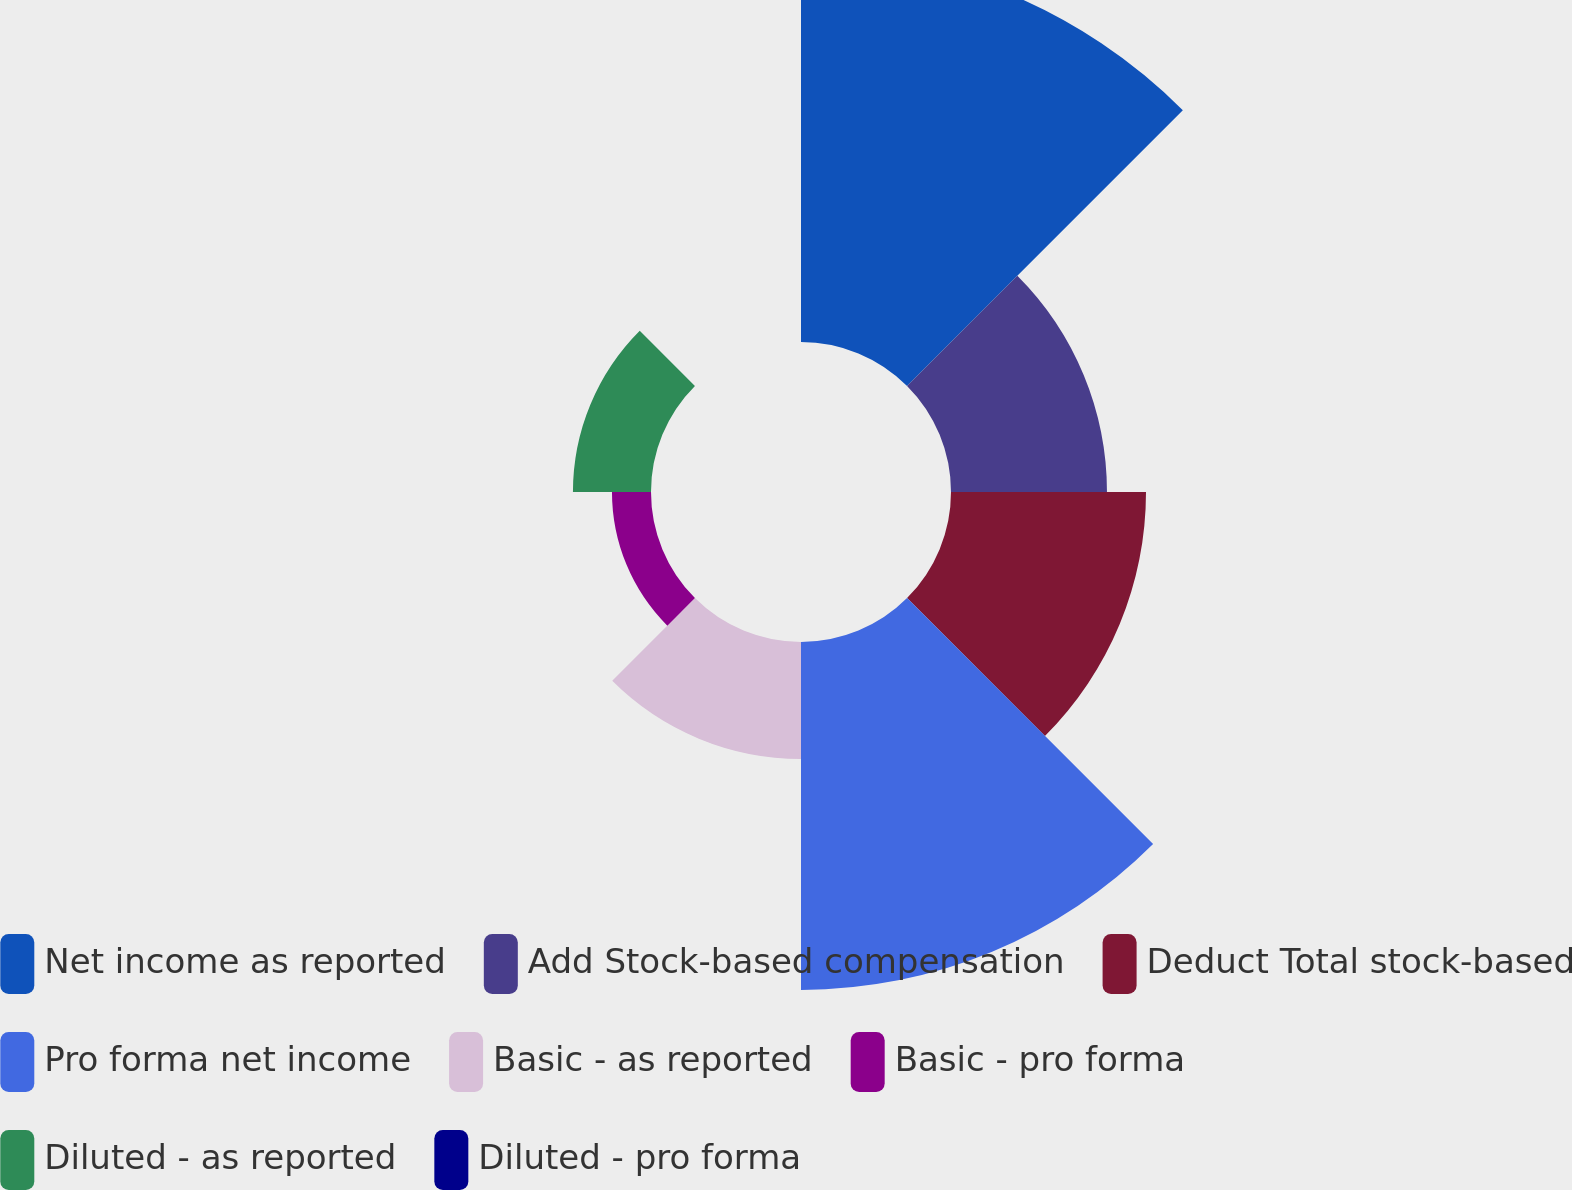<chart> <loc_0><loc_0><loc_500><loc_500><pie_chart><fcel>Net income as reported<fcel>Add Stock-based compensation<fcel>Deduct Total stock-based<fcel>Pro forma net income<fcel>Basic - as reported<fcel>Basic - pro forma<fcel>Diluted - as reported<fcel>Diluted - pro forma<nl><fcel>29.48%<fcel>11.79%<fcel>14.74%<fcel>26.3%<fcel>8.84%<fcel>2.95%<fcel>5.9%<fcel>0.0%<nl></chart> 